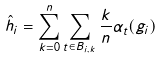Convert formula to latex. <formula><loc_0><loc_0><loc_500><loc_500>\hat { h } _ { i } = \sum _ { k = 0 } ^ { n } \sum _ { t \in B _ { i , k } } \frac { k } { n } \alpha _ { t } ( g _ { i } )</formula> 